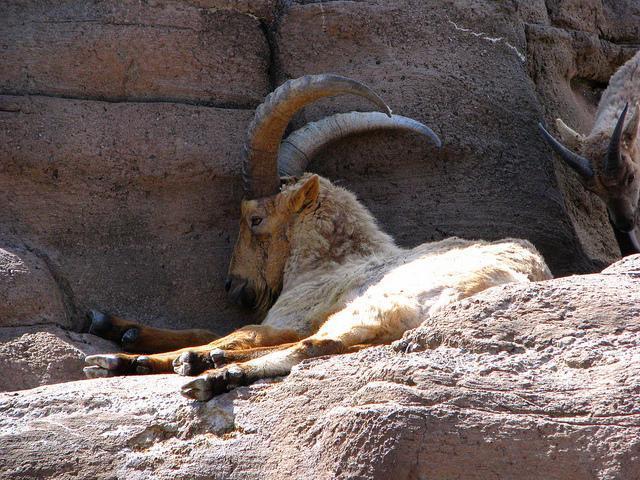How many animals are laying down?
Give a very brief answer. 1. How many sheep are in the picture?
Give a very brief answer. 2. How many people wearing a white cap are there?
Give a very brief answer. 0. 